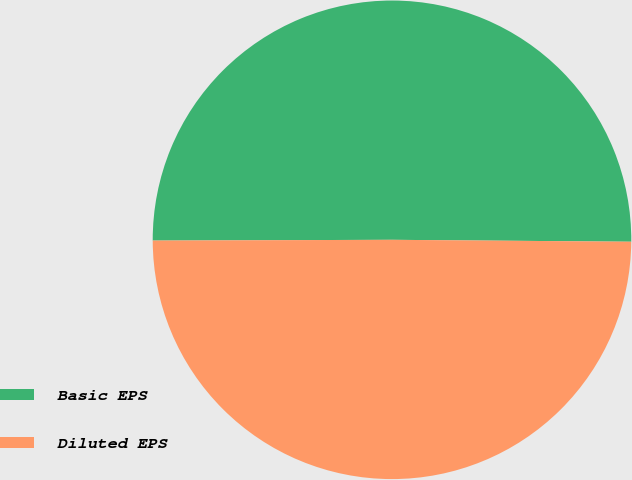Convert chart. <chart><loc_0><loc_0><loc_500><loc_500><pie_chart><fcel>Basic EPS<fcel>Diluted EPS<nl><fcel>50.18%<fcel>49.82%<nl></chart> 